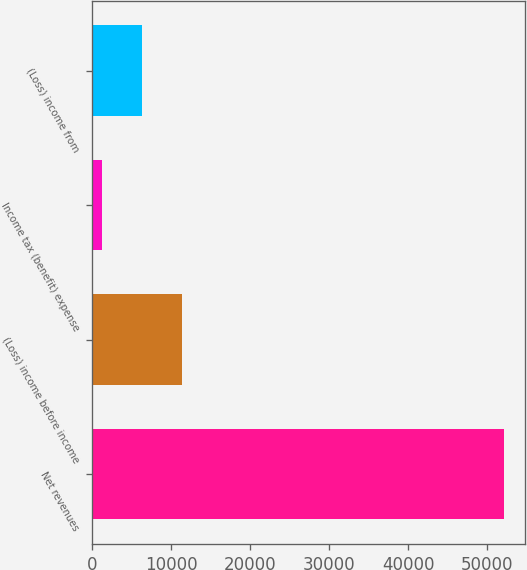Convert chart. <chart><loc_0><loc_0><loc_500><loc_500><bar_chart><fcel>Net revenues<fcel>(Loss) income before income<fcel>Income tax (benefit) expense<fcel>(Loss) income from<nl><fcel>52139<fcel>11370.2<fcel>1178<fcel>6274.1<nl></chart> 